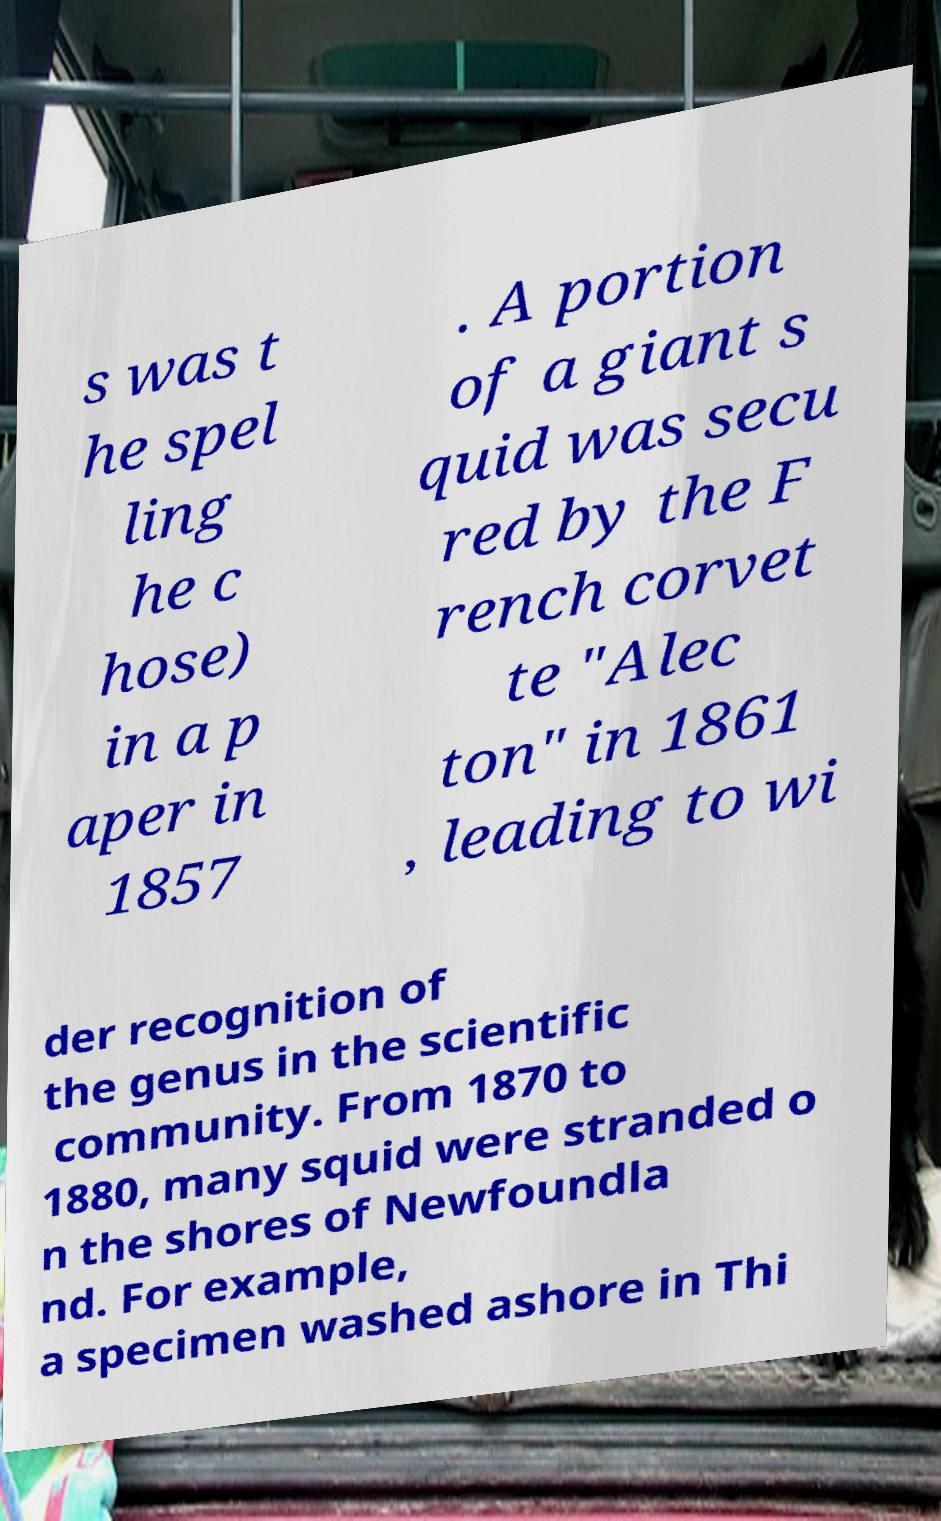Can you read and provide the text displayed in the image?This photo seems to have some interesting text. Can you extract and type it out for me? s was t he spel ling he c hose) in a p aper in 1857 . A portion of a giant s quid was secu red by the F rench corvet te "Alec ton" in 1861 , leading to wi der recognition of the genus in the scientific community. From 1870 to 1880, many squid were stranded o n the shores of Newfoundla nd. For example, a specimen washed ashore in Thi 